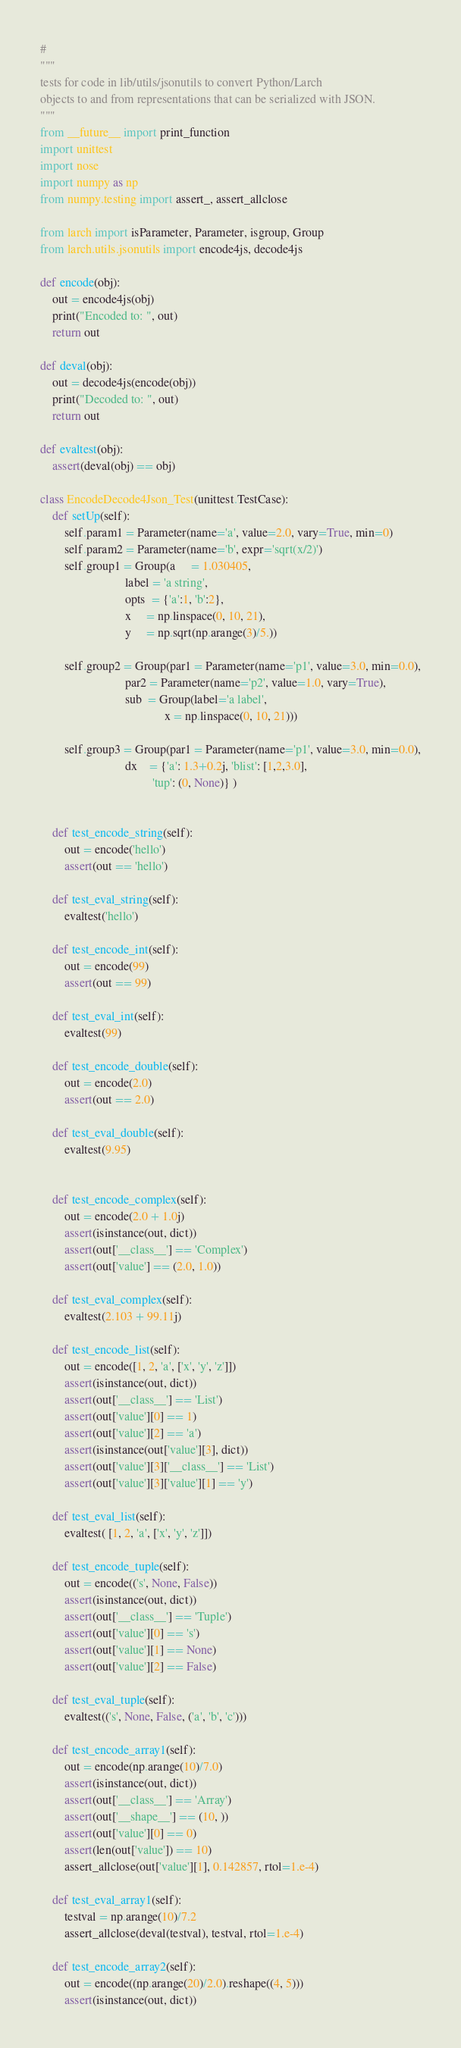Convert code to text. <code><loc_0><loc_0><loc_500><loc_500><_Python_>#
"""
tests for code in lib/utils/jsonutils to convert Python/Larch
objects to and from representations that can be serialized with JSON.
"""
from __future__ import print_function
import unittest
import nose
import numpy as np
from numpy.testing import assert_, assert_allclose

from larch import isParameter, Parameter, isgroup, Group
from larch.utils.jsonutils import encode4js, decode4js

def encode(obj):
    out = encode4js(obj)
    print("Encoded to: ", out)
    return out

def deval(obj):
    out = decode4js(encode(obj))
    print("Decoded to: ", out)
    return out

def evaltest(obj):
    assert(deval(obj) == obj)

class EncodeDecode4Json_Test(unittest.TestCase):
    def setUp(self):
        self.param1 = Parameter(name='a', value=2.0, vary=True, min=0)
        self.param2 = Parameter(name='b', expr='sqrt(x/2)')
        self.group1 = Group(a     = 1.030405,
                            label = 'a string',
                            opts  = {'a':1, 'b':2},
                            x     = np.linspace(0, 10, 21),
                            y     = np.sqrt(np.arange(3)/5.))

        self.group2 = Group(par1 = Parameter(name='p1', value=3.0, min=0.0),
                            par2 = Parameter(name='p2', value=1.0, vary=True),
                            sub  = Group(label='a label',
                                         x = np.linspace(0, 10, 21)))

        self.group3 = Group(par1 = Parameter(name='p1', value=3.0, min=0.0),
                            dx    = {'a': 1.3+0.2j, 'blist': [1,2,3.0],
                                     'tup': (0, None)} )


    def test_encode_string(self):
        out = encode('hello')
        assert(out == 'hello')

    def test_eval_string(self):
        evaltest('hello')

    def test_encode_int(self):
        out = encode(99)
        assert(out == 99)

    def test_eval_int(self):
        evaltest(99)

    def test_encode_double(self):
        out = encode(2.0)
        assert(out == 2.0)

    def test_eval_double(self):
        evaltest(9.95)


    def test_encode_complex(self):
        out = encode(2.0 + 1.0j)
        assert(isinstance(out, dict))
        assert(out['__class__'] == 'Complex')
        assert(out['value'] == (2.0, 1.0))

    def test_eval_complex(self):
        evaltest(2.103 + 99.11j)

    def test_encode_list(self):
        out = encode([1, 2, 'a', ['x', 'y', 'z']])
        assert(isinstance(out, dict))
        assert(out['__class__'] == 'List')
        assert(out['value'][0] == 1)
        assert(out['value'][2] == 'a')
        assert(isinstance(out['value'][3], dict))
        assert(out['value'][3]['__class__'] == 'List')
        assert(out['value'][3]['value'][1] == 'y')

    def test_eval_list(self):
        evaltest( [1, 2, 'a', ['x', 'y', 'z']])

    def test_encode_tuple(self):
        out = encode(('s', None, False))
        assert(isinstance(out, dict))
        assert(out['__class__'] == 'Tuple')
        assert(out['value'][0] == 's')
        assert(out['value'][1] == None)
        assert(out['value'][2] == False)

    def test_eval_tuple(self):
        evaltest(('s', None, False, ('a', 'b', 'c')))

    def test_encode_array1(self):
        out = encode(np.arange(10)/7.0)
        assert(isinstance(out, dict))
        assert(out['__class__'] == 'Array')
        assert(out['__shape__'] == (10, ))
        assert(out['value'][0] == 0)
        assert(len(out['value']) == 10)
        assert_allclose(out['value'][1], 0.142857, rtol=1.e-4)

    def test_eval_array1(self):
        testval = np.arange(10)/7.2
        assert_allclose(deval(testval), testval, rtol=1.e-4)

    def test_encode_array2(self):
        out = encode((np.arange(20)/2.0).reshape((4, 5)))
        assert(isinstance(out, dict))</code> 